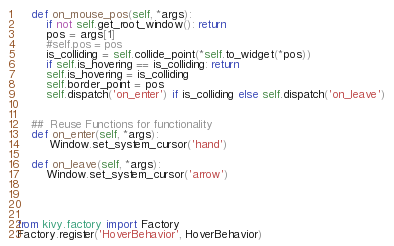<code> <loc_0><loc_0><loc_500><loc_500><_Python_>    def on_mouse_pos(self, *args):
        if not self.get_root_window(): return
        pos = args[1]
        #self.pos = pos
        is_colliding = self.collide_point(*self.to_widget(*pos))
        if self.is_hovering == is_colliding: return
        self.is_hovering = is_colliding 
        self.border_point = pos
        self.dispatch('on_enter') if is_colliding else self.dispatch('on_leave')
        
           
    ##  Reuse Functions for functionality
    def on_enter(self, *args):
         Window.set_system_cursor('hand')

    def on_leave(self, *args):
        Window.set_system_cursor('arrow')




from kivy.factory import Factory
Factory.register('HoverBehavior', HoverBehavior) </code> 